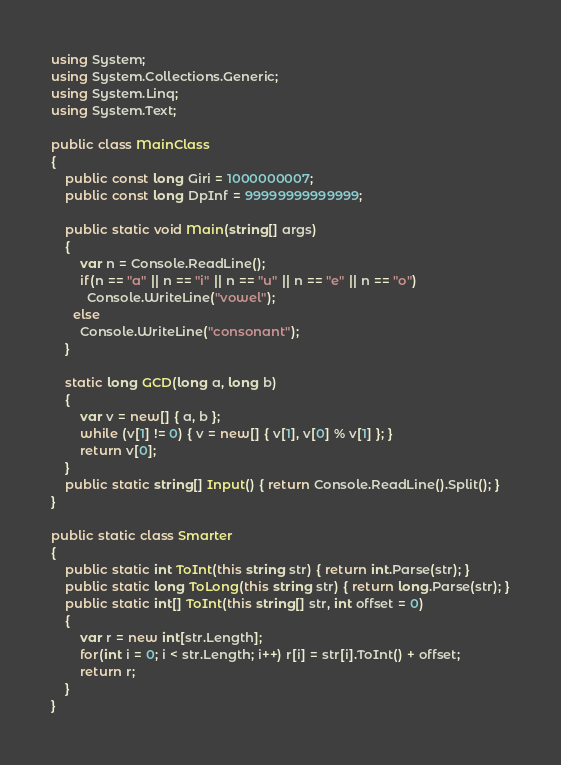Convert code to text. <code><loc_0><loc_0><loc_500><loc_500><_C#_>using System;
using System.Collections.Generic;
using System.Linq;
using System.Text;

public class MainClass
{
	public const long Giri = 1000000007;
	public const long DpInf = 99999999999999;
	
	public static void Main(string[] args)
	{
		var n = Console.ReadLine();
		if(n == "a" || n == "i" || n == "u" || n == "e" || n == "o")
          Console.WriteLine("vowel");
      else
        Console.WriteLine("consonant");
	}
	
	static long GCD(long a, long b)
	{
		var v = new[] { a, b };
		while (v[1] != 0) { v = new[] { v[1], v[0] % v[1] }; }
		return v[0];
	}
	public static string[] Input() { return Console.ReadLine().Split(); }
}

public static class Smarter
{
	public static int ToInt(this string str) { return int.Parse(str); }
	public static long ToLong(this string str) { return long.Parse(str); }
	public static int[] ToInt(this string[] str, int offset = 0)
	{
		var r = new int[str.Length];
		for(int i = 0; i < str.Length; i++) r[i] = str[i].ToInt() + offset;
		return r;
	}
}</code> 